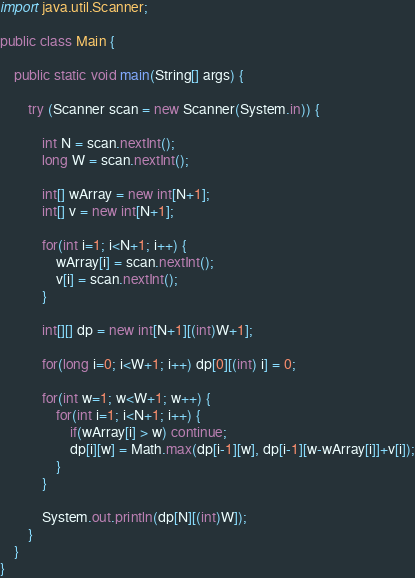<code> <loc_0><loc_0><loc_500><loc_500><_Java_>import java.util.Scanner;

public class Main {

	public static void main(String[] args) {

		try (Scanner scan = new Scanner(System.in)) {

			int N = scan.nextInt();
			long W = scan.nextInt();

			int[] wArray = new int[N+1];
			int[] v = new int[N+1];
			
			for(int i=1; i<N+1; i++) {
				wArray[i] = scan.nextInt();
				v[i] = scan.nextInt();
			}
			
			int[][] dp = new int[N+1][(int)W+1];
			
			for(long i=0; i<W+1; i++) dp[0][(int) i] = 0;
			
			for(int w=1; w<W+1; w++) {
				for(int i=1; i<N+1; i++) {
					if(wArray[i] > w) continue;
					dp[i][w] = Math.max(dp[i-1][w], dp[i-1][w-wArray[i]]+v[i]);
				}
			}
			
			System.out.println(dp[N][(int)W]);
		}
	}
}</code> 